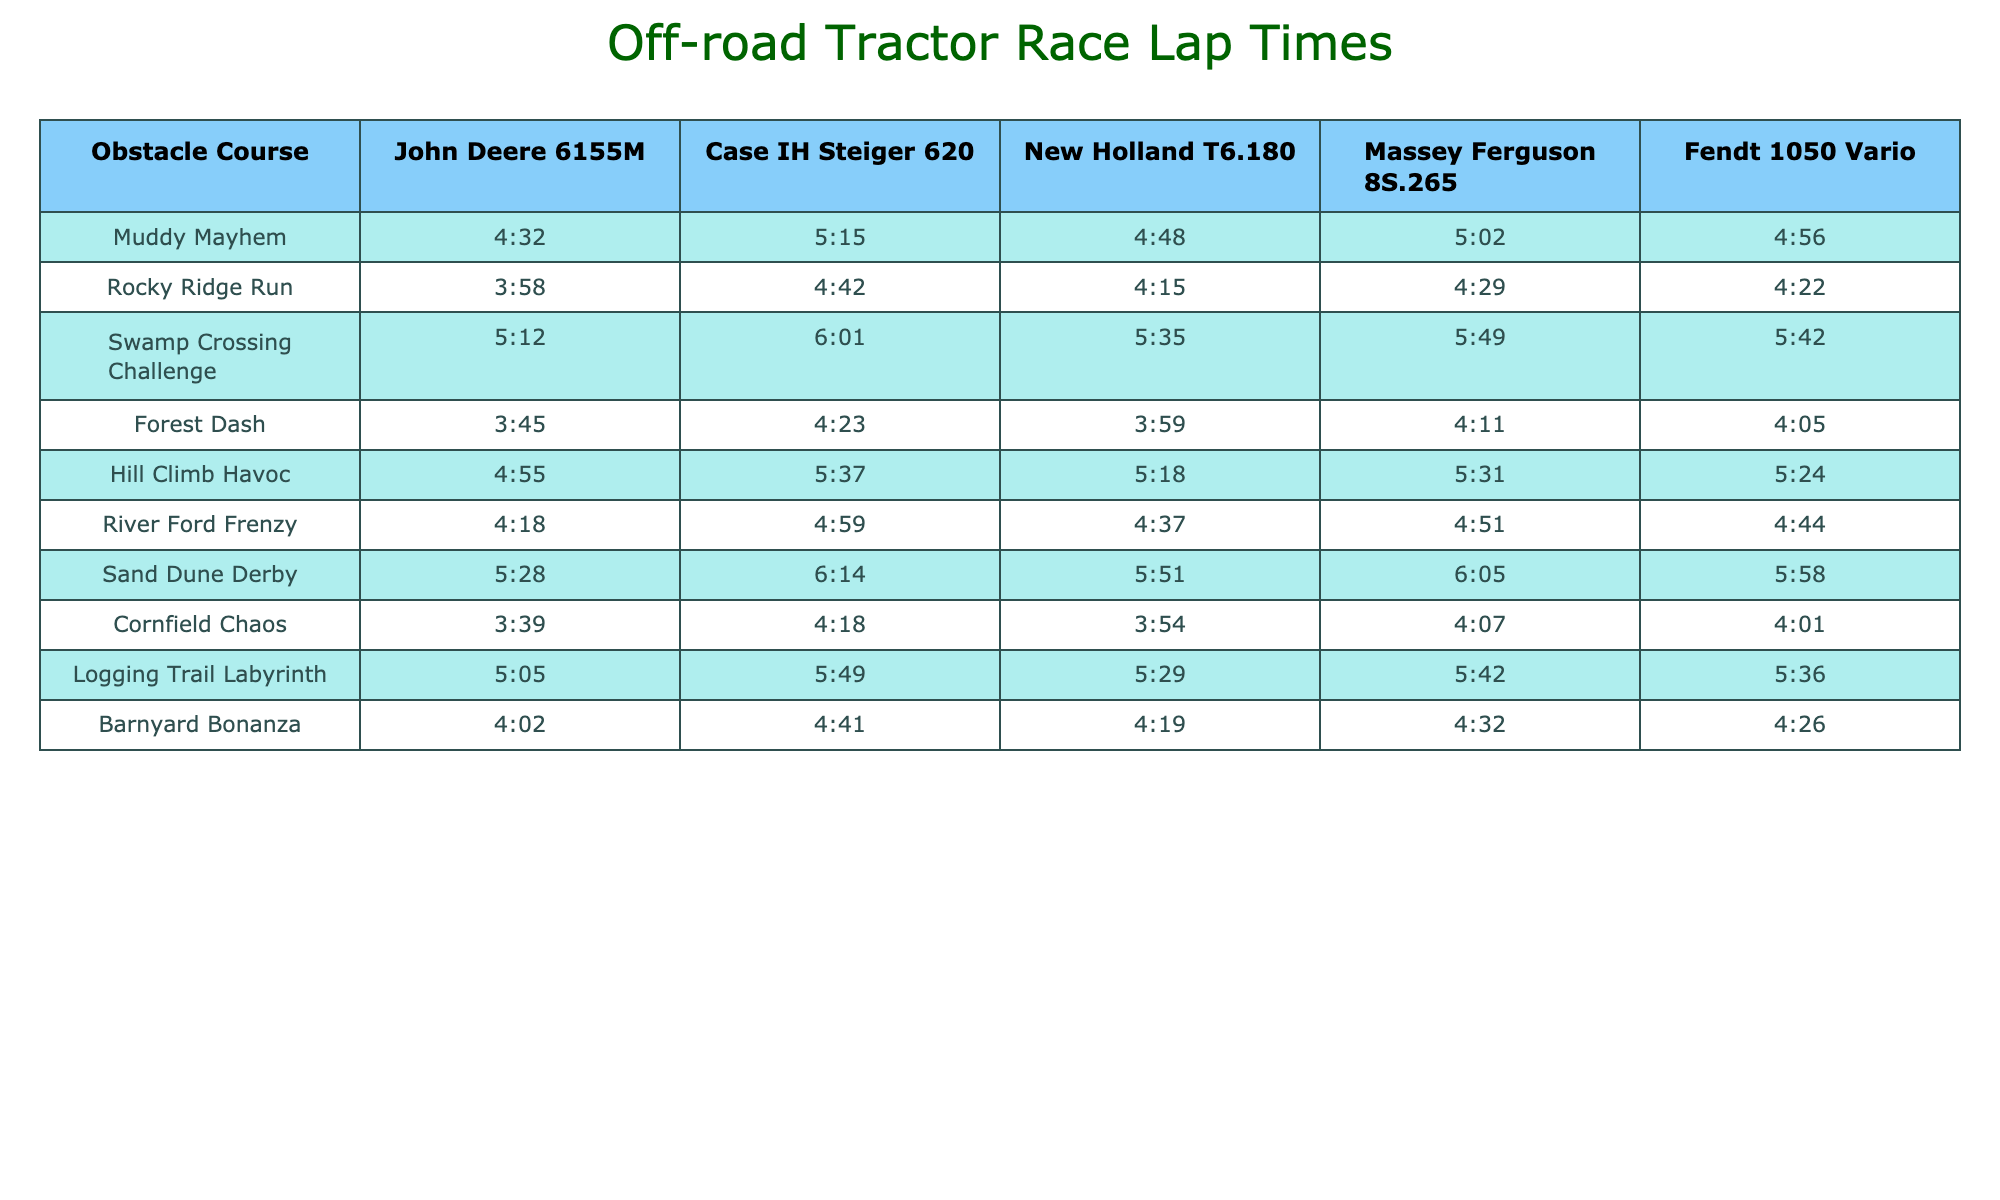What's the lap time for the John Deere 6155M on the Muddy Mayhem course? The table shows that the lap time for the John Deere 6155M on the Muddy Mayhem course is 4:32.
Answer: 4:32 Which tractor had the longest lap time on the Swamp Crossing Challenge? Looking at the Swamp Crossing Challenge column, the Case IH Steiger 620 has the longest lap time of 6:01.
Answer: Case IH Steiger 620 What is the average lap time for the New Holland T6.180 across all courses? To find the average, add all the lap times for New Holland T6.180: 4:48 + 4:15 + 5:35 + 3:59 + 5:18 + 4:37 + 5:51 + 3:54 + 4:19 = 43:56. Convert this to minutes as 43 minutes and 56 seconds; divide by 9 (the number of courses) gives approximately 4:53.
Answer: 4:53 Did the Massey Ferguson 8S.265 have a lap time under 5 minutes in any course? Checking the table, the Massey Ferguson 8S.265 had lap times over 5 minutes except for the Forest Dash, which is 4:11. Therefore, yes, it did have a lap time under 5 minutes.
Answer: Yes Which tractor performed the best overall, based on the fastest lap times? By reviewing all the lap times, the John Deere 6155M has the fastest times in Muddy Mayhem, Rocky Ridge Run, Forest Dash, Cornfield Chaos, and Barnyard Bonanza. It is the best performer overall since it has the most fastest lap times.
Answer: John Deere 6155M What is the total lap time difference between the fastest and slowest tractors in the Hill Climb Havoc? The fastest time in Hill Climb Havoc is for the John Deere 6155M at 4:55 and the slowest is for the Case IH Steiger 620 at 5:37. The time difference is 5:37 - 4:55 = 0:42 (42 seconds).
Answer: 0:42 How many courses did the Case IH Steiger 620 complete in under 5 minutes? By checking the lap times for the Case IH Steiger 620 across all courses, it completed only one course (Forest Dash) in under 5 minutes.
Answer: 1 Which obstacle course had the fastest average lap time across all tractors? The average lap times for each course can be calculated and compared. The School Dash has the fastest average time of 4:07 across the tractors.
Answer: Cornfield Chaos What is the lap time difference between the fastest and slowest laps for the New Holland T6.180? The fastest lap time is on the Forest Dash (3:59) and the slowest on Swamp Crossing Challenge (5:35). The difference is 5:35 - 3:59 = 1:36 (96 seconds).
Answer: 1:36 